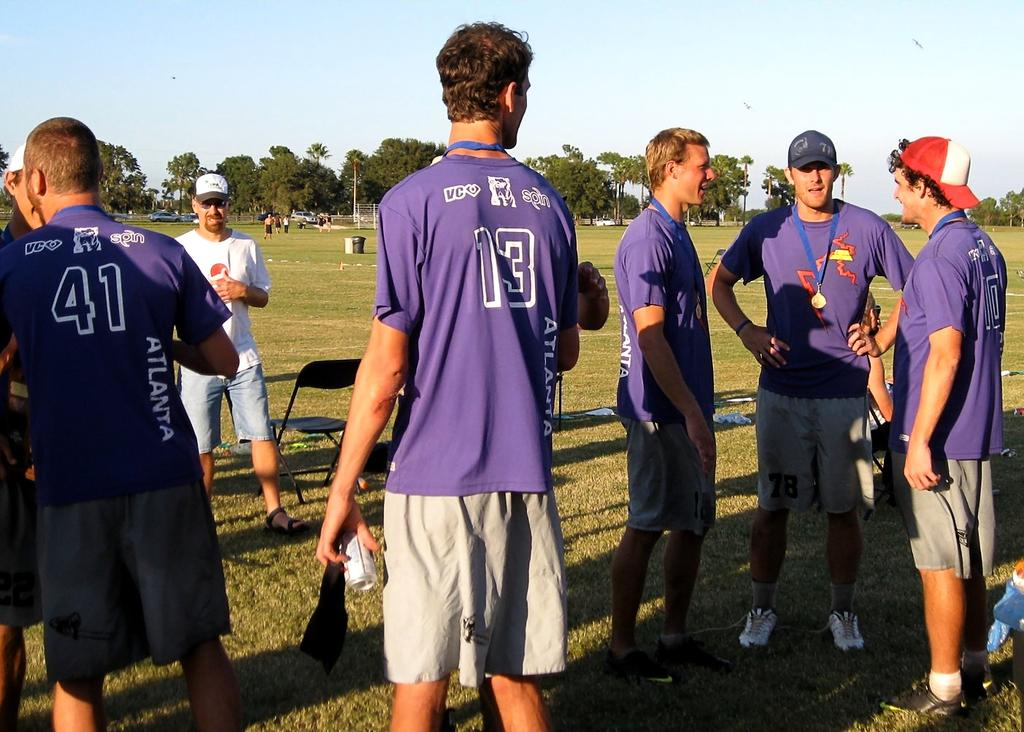<image>
Provide a brief description of the given image. A group of athletes in purple shirts, one with the number 41 on his back, stand in a field. 